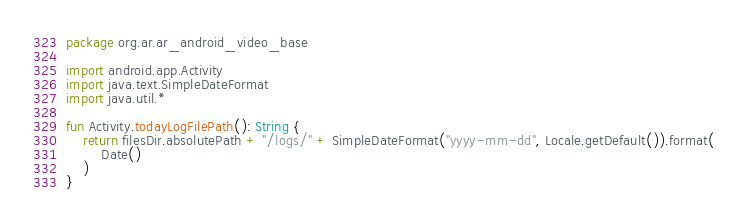<code> <loc_0><loc_0><loc_500><loc_500><_Kotlin_>package org.ar.ar_android_video_base

import android.app.Activity
import java.text.SimpleDateFormat
import java.util.*

fun Activity.todayLogFilePath(): String {
    return filesDir.absolutePath + "/logs/" + SimpleDateFormat("yyyy-mm-dd", Locale.getDefault()).format(
        Date()
    )
}</code> 